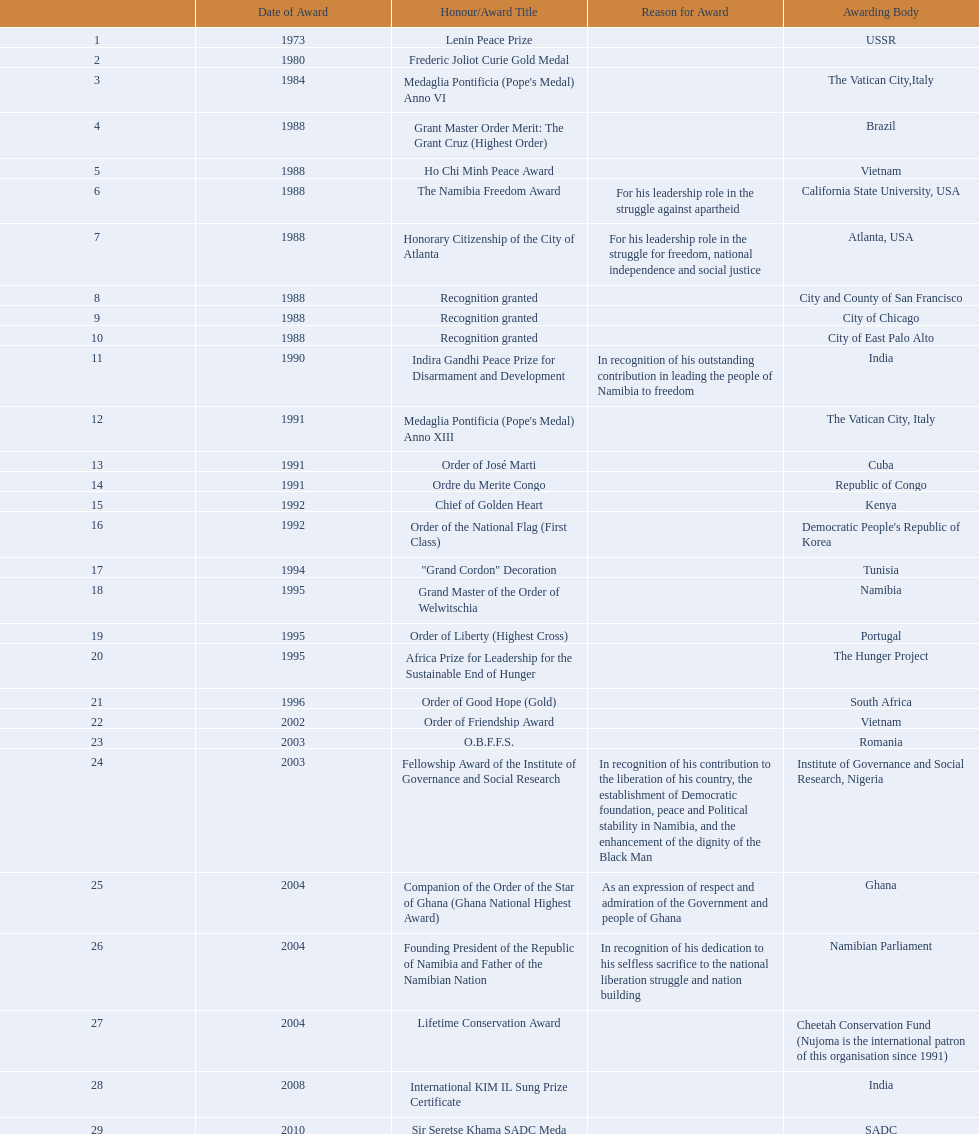What awards has sam nujoma been awarded? Lenin Peace Prize, Frederic Joliot Curie Gold Medal, Medaglia Pontificia (Pope's Medal) Anno VI, Grant Master Order Merit: The Grant Cruz (Highest Order), Ho Chi Minh Peace Award, The Namibia Freedom Award, Honorary Citizenship of the City of Atlanta, Recognition granted, Recognition granted, Recognition granted, Indira Gandhi Peace Prize for Disarmament and Development, Medaglia Pontificia (Pope's Medal) Anno XIII, Order of José Marti, Ordre du Merite Congo, Chief of Golden Heart, Order of the National Flag (First Class), "Grand Cordon" Decoration, Grand Master of the Order of Welwitschia, Order of Liberty (Highest Cross), Africa Prize for Leadership for the Sustainable End of Hunger, Order of Good Hope (Gold), Order of Friendship Award, O.B.F.F.S., Fellowship Award of the Institute of Governance and Social Research, Companion of the Order of the Star of Ghana (Ghana National Highest Award), Founding President of the Republic of Namibia and Father of the Namibian Nation, Lifetime Conservation Award, International KIM IL Sung Prize Certificate, Sir Seretse Khama SADC Meda. By which awarding body did sam nujoma receive the o.b.f.f.s award? Romania. 